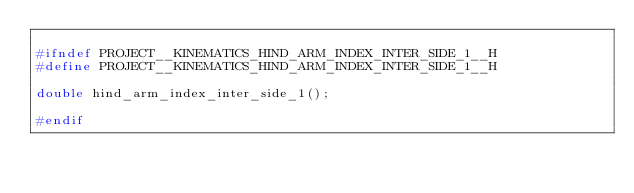<code> <loc_0><loc_0><loc_500><loc_500><_C_>
#ifndef PROJECT__KINEMATICS_HIND_ARM_INDEX_INTER_SIDE_1__H
#define PROJECT__KINEMATICS_HIND_ARM_INDEX_INTER_SIDE_1__H

double hind_arm_index_inter_side_1();

#endif

</code> 